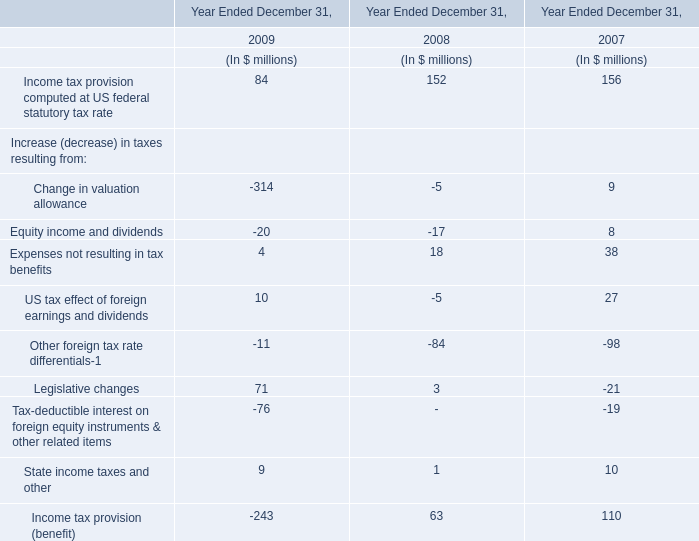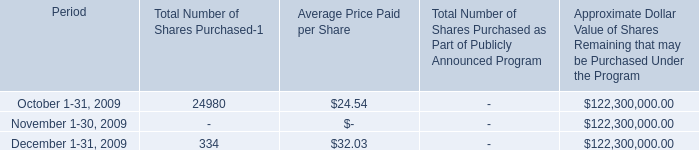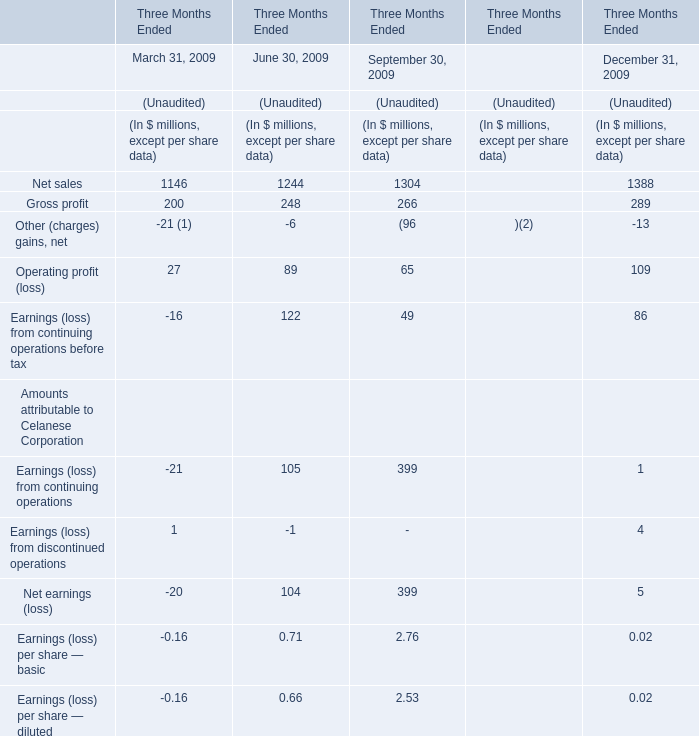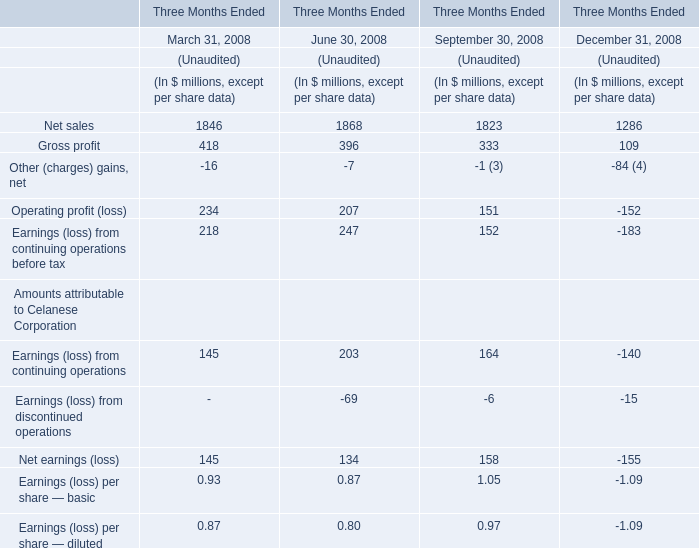What is the sum of Gross profit for March 31, 2009 and Legislative changes in 2008? (in million) 
Computations: (200 + 3)
Answer: 203.0. 